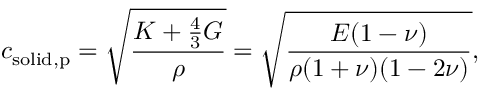<formula> <loc_0><loc_0><loc_500><loc_500>c _ { s o l i d , p } = { \sqrt { \frac { K + { \frac { 4 } { 3 } } G } { \rho } } } = { \sqrt { \frac { E ( 1 - \nu ) } { \rho ( 1 + \nu ) ( 1 - 2 \nu ) } } } ,</formula> 